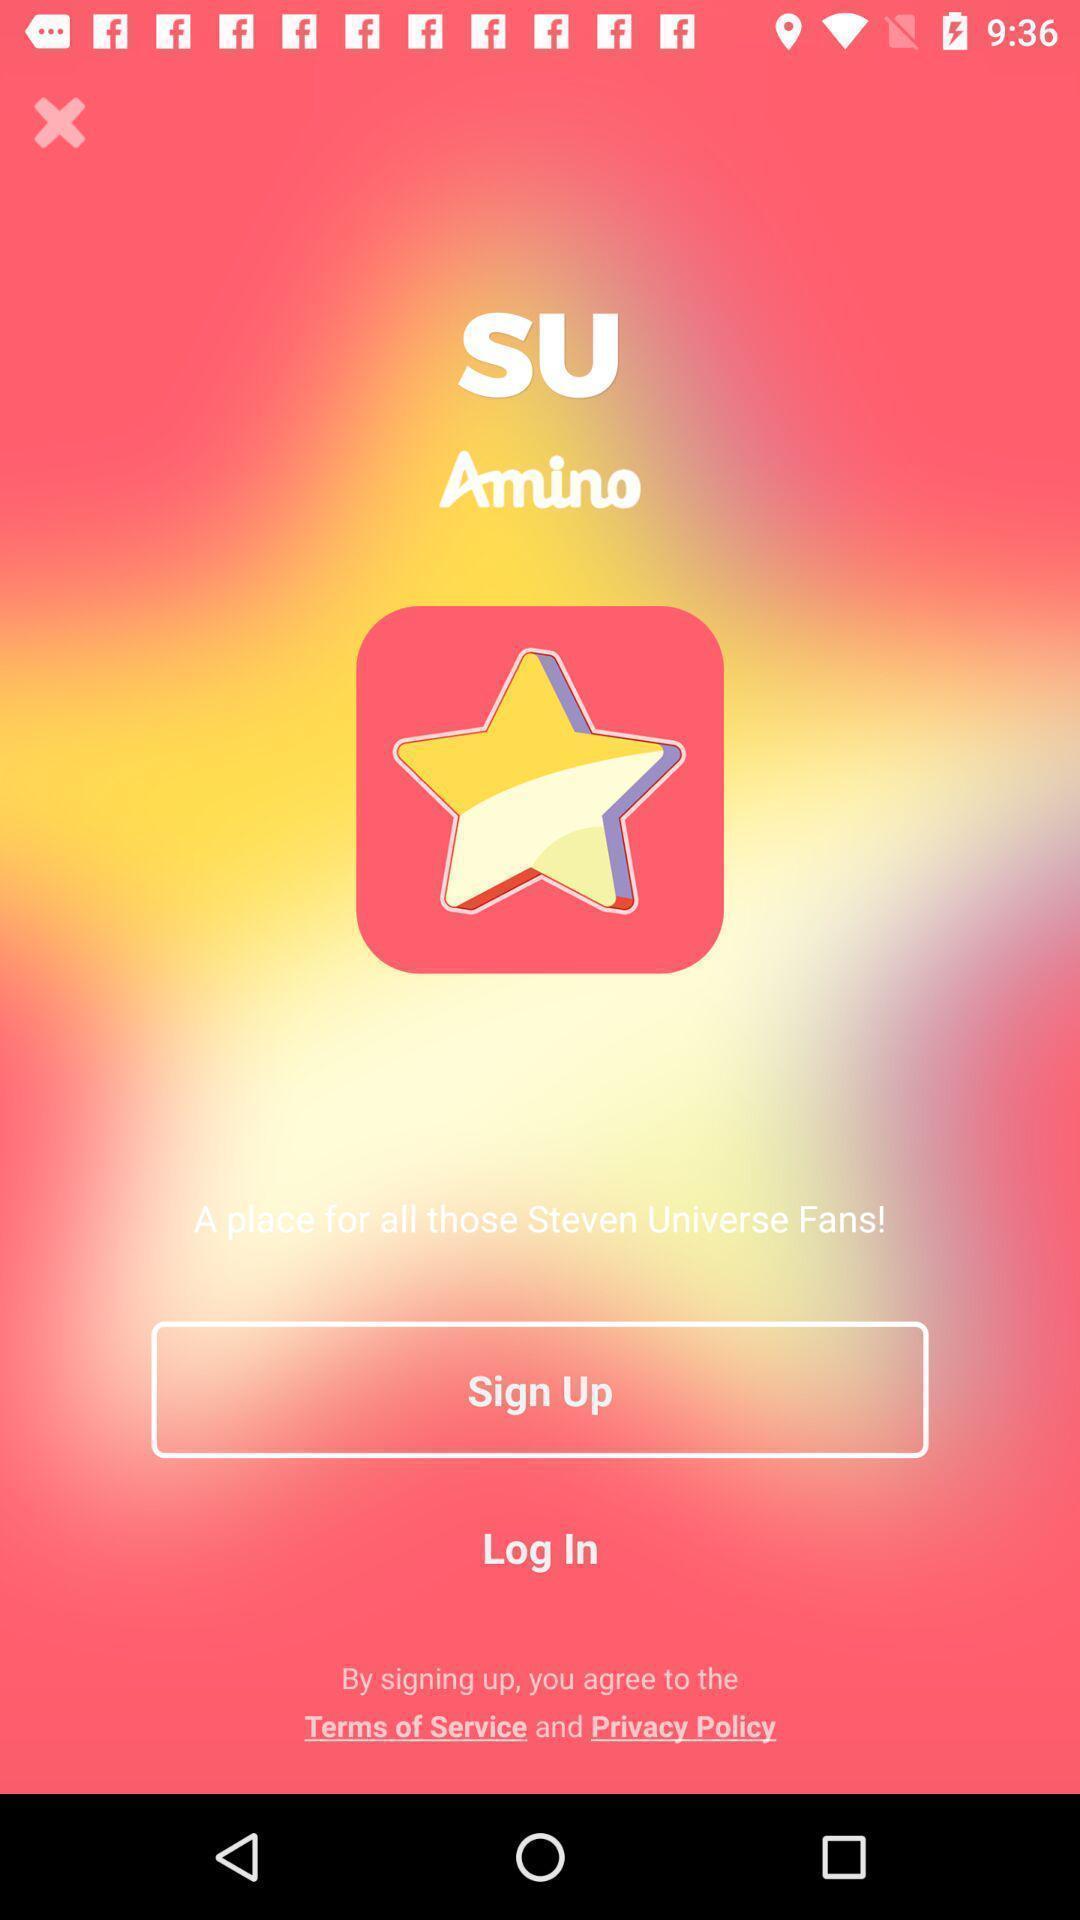Describe the key features of this screenshot. Welcome page of a chat app. 